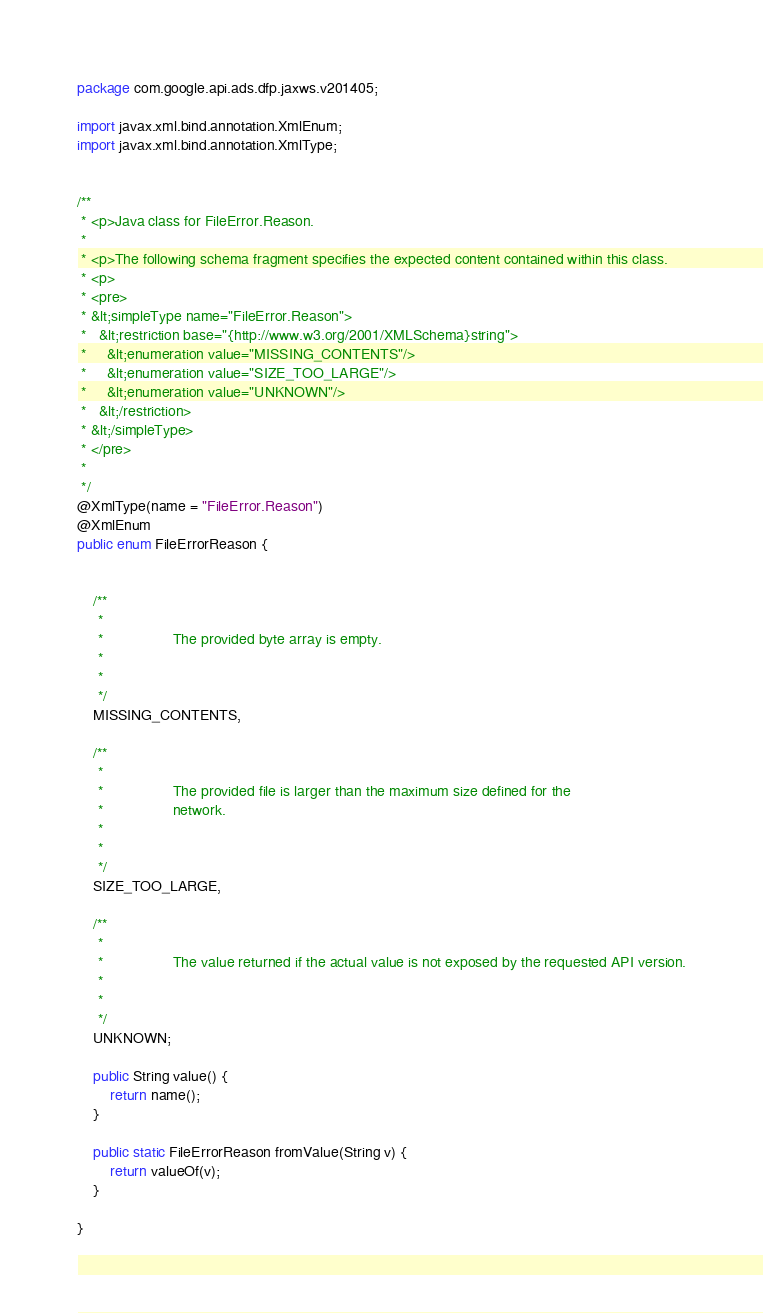Convert code to text. <code><loc_0><loc_0><loc_500><loc_500><_Java_>
package com.google.api.ads.dfp.jaxws.v201405;

import javax.xml.bind.annotation.XmlEnum;
import javax.xml.bind.annotation.XmlType;


/**
 * <p>Java class for FileError.Reason.
 * 
 * <p>The following schema fragment specifies the expected content contained within this class.
 * <p>
 * <pre>
 * &lt;simpleType name="FileError.Reason">
 *   &lt;restriction base="{http://www.w3.org/2001/XMLSchema}string">
 *     &lt;enumeration value="MISSING_CONTENTS"/>
 *     &lt;enumeration value="SIZE_TOO_LARGE"/>
 *     &lt;enumeration value="UNKNOWN"/>
 *   &lt;/restriction>
 * &lt;/simpleType>
 * </pre>
 * 
 */
@XmlType(name = "FileError.Reason")
@XmlEnum
public enum FileErrorReason {


    /**
     * 
     *                 The provided byte array is empty.
     *               
     * 
     */
    MISSING_CONTENTS,

    /**
     * 
     *                 The provided file is larger than the maximum size defined for the
     *                 network.
     *               
     * 
     */
    SIZE_TOO_LARGE,

    /**
     * 
     *                 The value returned if the actual value is not exposed by the requested API version.
     *               
     * 
     */
    UNKNOWN;

    public String value() {
        return name();
    }

    public static FileErrorReason fromValue(String v) {
        return valueOf(v);
    }

}
</code> 